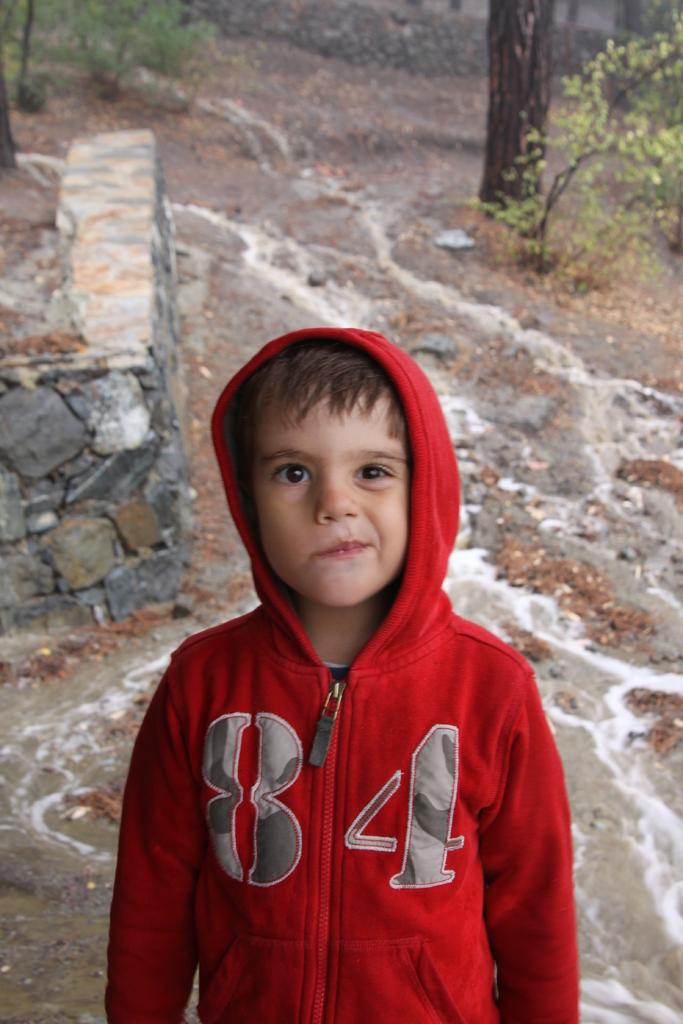<image>
Describe the image concisely. a little boy wearing a red hoodie with the numbers "84" on it 